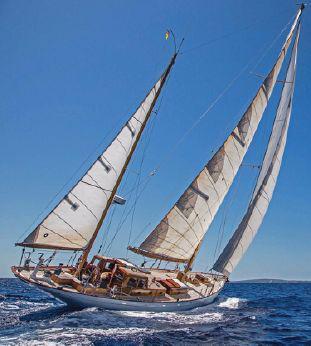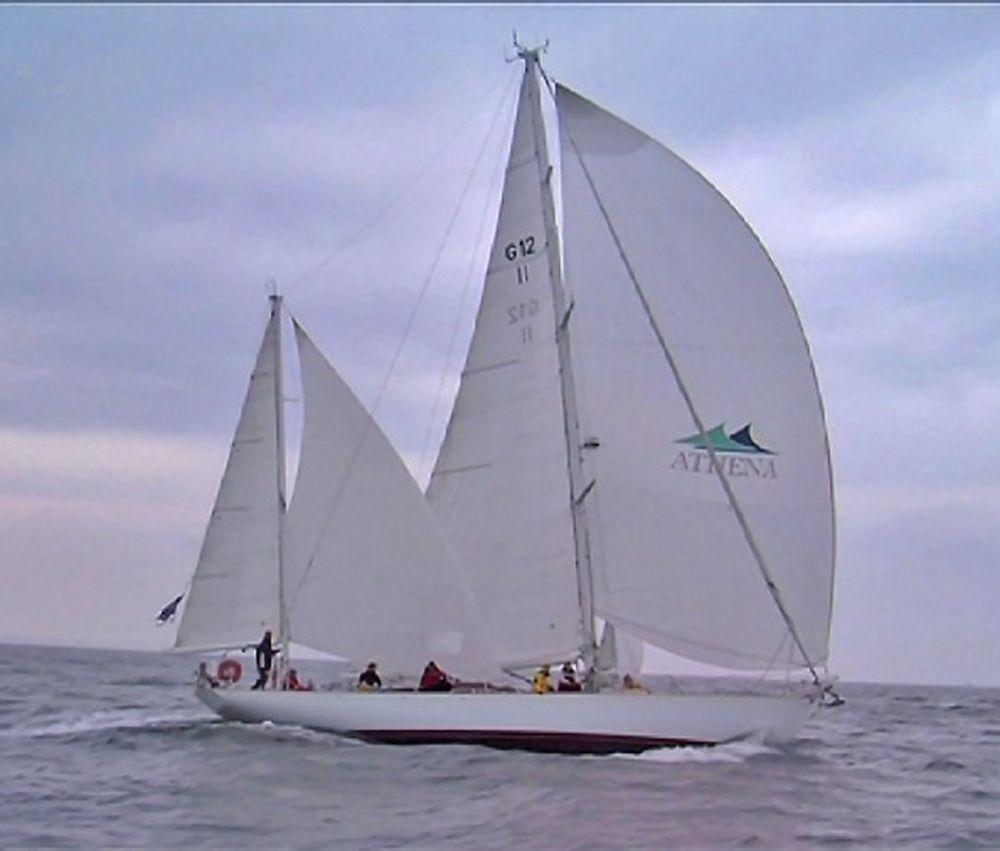The first image is the image on the left, the second image is the image on the right. Given the left and right images, does the statement "A sailboat has only 1 large sail and 1 small sail unfurled." hold true? Answer yes or no. No. The first image is the image on the left, the second image is the image on the right. Evaluate the accuracy of this statement regarding the images: "A boat has exactly two sails.". Is it true? Answer yes or no. No. 